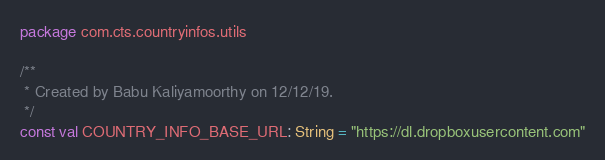<code> <loc_0><loc_0><loc_500><loc_500><_Kotlin_>package com.cts.countryinfos.utils

/**
 * Created by Babu Kaliyamoorthy on 12/12/19.
 */
const val COUNTRY_INFO_BASE_URL: String = "https://dl.dropboxusercontent.com"</code> 